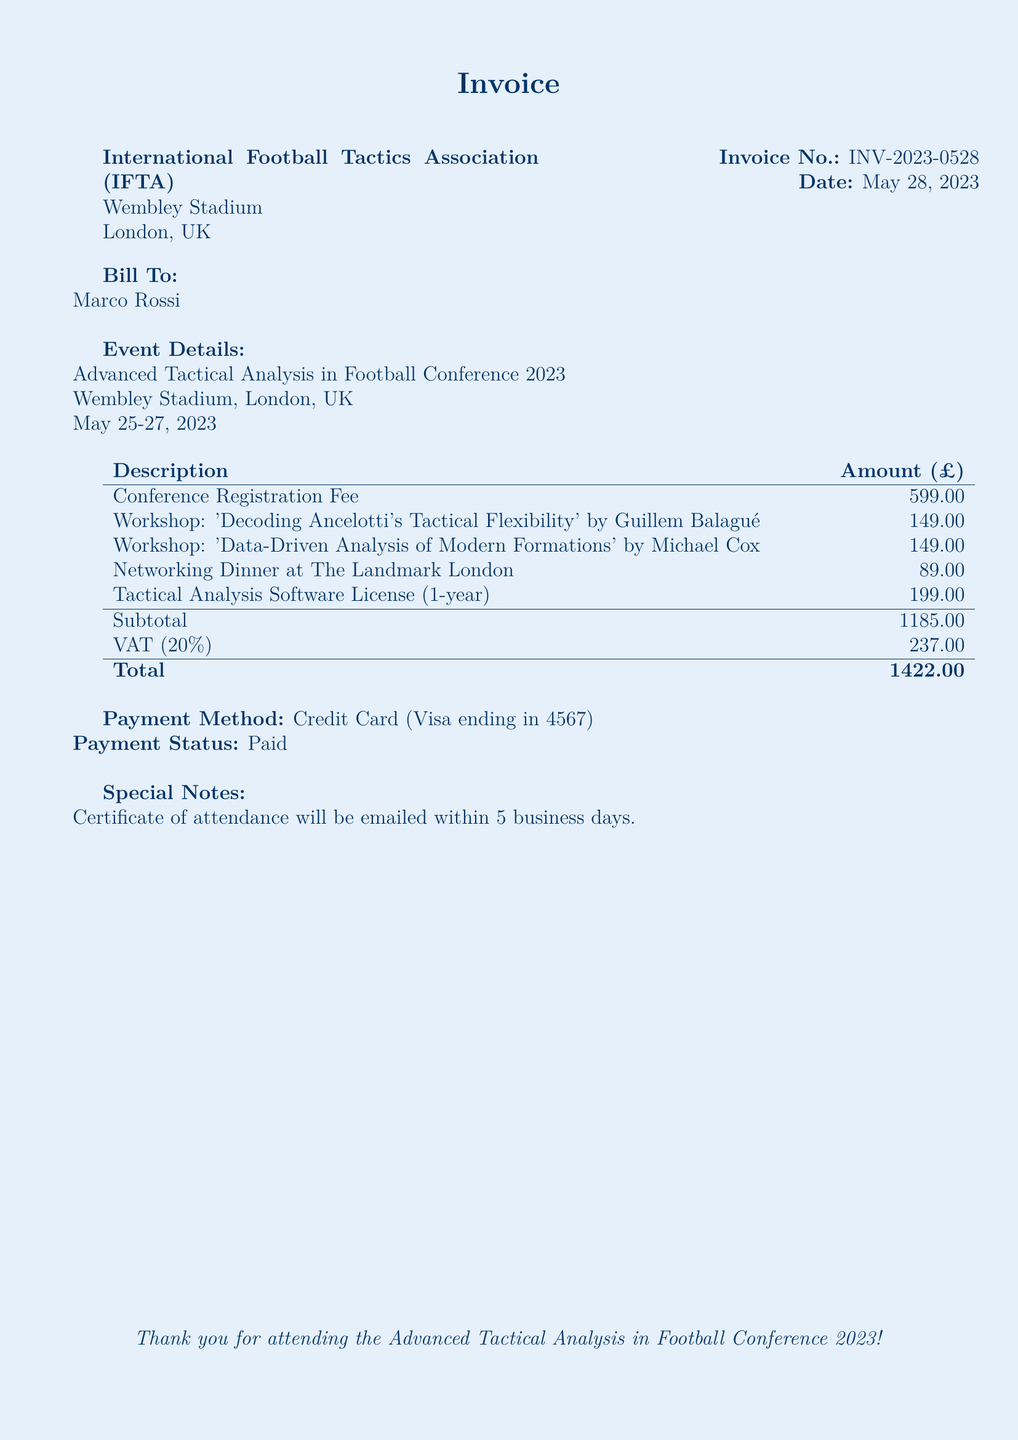What is the invoice number? The invoice number is clearly stated in the document.
Answer: INV-2023-0528 What is the date of the invoice? The document indicates the date when the invoice was issued.
Answer: May 28, 2023 Who is listed as the recipient of the bill? The document specifies the individual to whom the invoice is addressed.
Answer: Marco Rossi What is the VAT percentage applied? The document states the VAT rate applied to the subtotal.
Answer: 20% What was the total amount charged? The total amount charged is explicitly detailed in the document.
Answer: 1422.00 How much was charged for the networking dinner? The amount for the networking dinner is mentioned in the itemized list.
Answer: 89.00 Which workshop focused on Carlo Ancelotti's tactics? The document specifies the title of the workshop related to Ancelotti.
Answer: 'Decoding Ancelotti's Tactical Flexibility' What is the venue for the conference? The document mentions the location where the conference took place.
Answer: Wembley Stadium, London, UK What method of payment was used? The payment method is clearly indicated in the document.
Answer: Credit Card (Visa ending in 4567) 